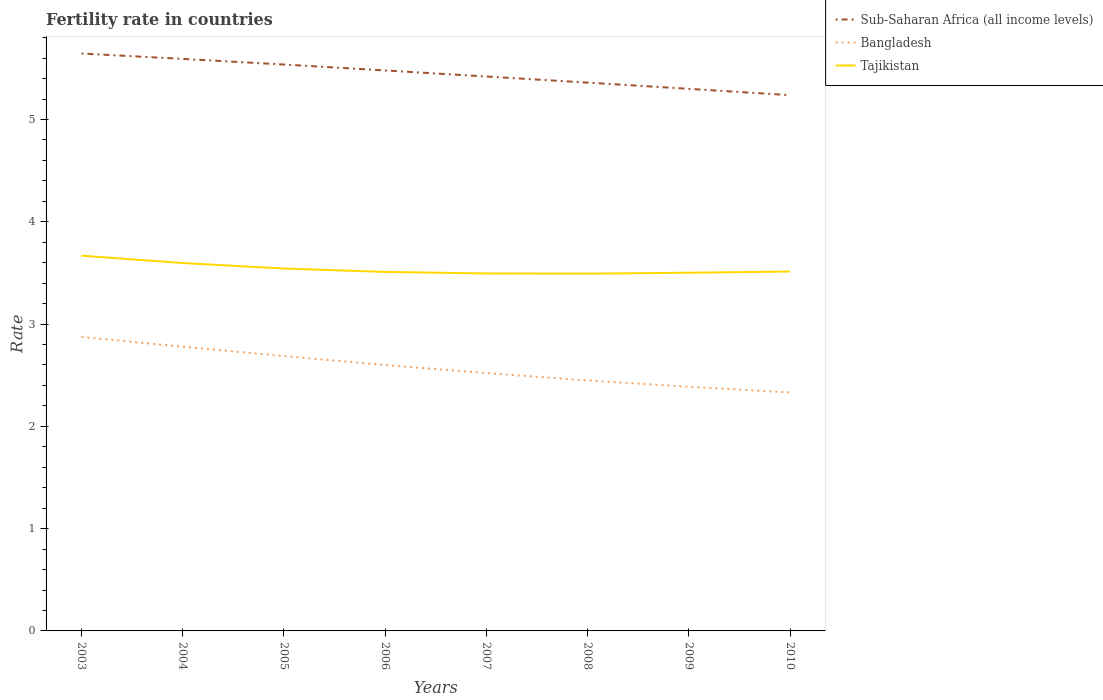Is the number of lines equal to the number of legend labels?
Ensure brevity in your answer.  Yes. Across all years, what is the maximum fertility rate in Sub-Saharan Africa (all income levels)?
Your answer should be compact. 5.24. In which year was the fertility rate in Tajikistan maximum?
Ensure brevity in your answer.  2008. What is the total fertility rate in Sub-Saharan Africa (all income levels) in the graph?
Your answer should be very brief. 0.41. What is the difference between the highest and the second highest fertility rate in Bangladesh?
Ensure brevity in your answer.  0.54. What is the difference between the highest and the lowest fertility rate in Tajikistan?
Your response must be concise. 3. Is the fertility rate in Bangladesh strictly greater than the fertility rate in Tajikistan over the years?
Keep it short and to the point. Yes. How many years are there in the graph?
Offer a very short reply. 8. What is the difference between two consecutive major ticks on the Y-axis?
Offer a terse response. 1. Does the graph contain grids?
Provide a succinct answer. No. Where does the legend appear in the graph?
Provide a succinct answer. Top right. How many legend labels are there?
Ensure brevity in your answer.  3. How are the legend labels stacked?
Offer a very short reply. Vertical. What is the title of the graph?
Your answer should be very brief. Fertility rate in countries. What is the label or title of the X-axis?
Ensure brevity in your answer.  Years. What is the label or title of the Y-axis?
Your answer should be very brief. Rate. What is the Rate of Sub-Saharan Africa (all income levels) in 2003?
Your response must be concise. 5.65. What is the Rate in Bangladesh in 2003?
Offer a very short reply. 2.87. What is the Rate in Tajikistan in 2003?
Offer a terse response. 3.67. What is the Rate in Sub-Saharan Africa (all income levels) in 2004?
Ensure brevity in your answer.  5.59. What is the Rate in Bangladesh in 2004?
Provide a succinct answer. 2.78. What is the Rate of Tajikistan in 2004?
Keep it short and to the point. 3.6. What is the Rate in Sub-Saharan Africa (all income levels) in 2005?
Give a very brief answer. 5.54. What is the Rate in Bangladesh in 2005?
Your response must be concise. 2.69. What is the Rate in Tajikistan in 2005?
Offer a terse response. 3.54. What is the Rate in Sub-Saharan Africa (all income levels) in 2006?
Your answer should be compact. 5.48. What is the Rate of Tajikistan in 2006?
Your response must be concise. 3.51. What is the Rate in Sub-Saharan Africa (all income levels) in 2007?
Your response must be concise. 5.42. What is the Rate of Bangladesh in 2007?
Provide a succinct answer. 2.52. What is the Rate in Tajikistan in 2007?
Provide a succinct answer. 3.5. What is the Rate of Sub-Saharan Africa (all income levels) in 2008?
Ensure brevity in your answer.  5.36. What is the Rate of Bangladesh in 2008?
Your answer should be compact. 2.45. What is the Rate of Tajikistan in 2008?
Your response must be concise. 3.49. What is the Rate in Sub-Saharan Africa (all income levels) in 2009?
Keep it short and to the point. 5.3. What is the Rate of Bangladesh in 2009?
Provide a succinct answer. 2.39. What is the Rate in Tajikistan in 2009?
Keep it short and to the point. 3.5. What is the Rate in Sub-Saharan Africa (all income levels) in 2010?
Provide a succinct answer. 5.24. What is the Rate in Bangladesh in 2010?
Provide a succinct answer. 2.33. What is the Rate of Tajikistan in 2010?
Offer a terse response. 3.51. Across all years, what is the maximum Rate in Sub-Saharan Africa (all income levels)?
Your answer should be very brief. 5.65. Across all years, what is the maximum Rate of Bangladesh?
Provide a succinct answer. 2.87. Across all years, what is the maximum Rate of Tajikistan?
Provide a short and direct response. 3.67. Across all years, what is the minimum Rate in Sub-Saharan Africa (all income levels)?
Your answer should be very brief. 5.24. Across all years, what is the minimum Rate of Bangladesh?
Provide a short and direct response. 2.33. Across all years, what is the minimum Rate of Tajikistan?
Give a very brief answer. 3.49. What is the total Rate in Sub-Saharan Africa (all income levels) in the graph?
Offer a terse response. 43.58. What is the total Rate of Bangladesh in the graph?
Provide a succinct answer. 20.63. What is the total Rate in Tajikistan in the graph?
Provide a succinct answer. 28.32. What is the difference between the Rate in Sub-Saharan Africa (all income levels) in 2003 and that in 2004?
Provide a short and direct response. 0.05. What is the difference between the Rate in Bangladesh in 2003 and that in 2004?
Give a very brief answer. 0.1. What is the difference between the Rate in Tajikistan in 2003 and that in 2004?
Offer a terse response. 0.07. What is the difference between the Rate in Sub-Saharan Africa (all income levels) in 2003 and that in 2005?
Provide a short and direct response. 0.11. What is the difference between the Rate in Bangladesh in 2003 and that in 2005?
Make the answer very short. 0.19. What is the difference between the Rate of Tajikistan in 2003 and that in 2005?
Your answer should be very brief. 0.13. What is the difference between the Rate of Sub-Saharan Africa (all income levels) in 2003 and that in 2006?
Keep it short and to the point. 0.17. What is the difference between the Rate in Bangladesh in 2003 and that in 2006?
Give a very brief answer. 0.27. What is the difference between the Rate of Tajikistan in 2003 and that in 2006?
Your response must be concise. 0.16. What is the difference between the Rate of Sub-Saharan Africa (all income levels) in 2003 and that in 2007?
Ensure brevity in your answer.  0.22. What is the difference between the Rate of Bangladesh in 2003 and that in 2007?
Your response must be concise. 0.35. What is the difference between the Rate of Tajikistan in 2003 and that in 2007?
Your response must be concise. 0.17. What is the difference between the Rate in Sub-Saharan Africa (all income levels) in 2003 and that in 2008?
Keep it short and to the point. 0.28. What is the difference between the Rate of Bangladesh in 2003 and that in 2008?
Make the answer very short. 0.42. What is the difference between the Rate in Tajikistan in 2003 and that in 2008?
Provide a succinct answer. 0.18. What is the difference between the Rate of Sub-Saharan Africa (all income levels) in 2003 and that in 2009?
Keep it short and to the point. 0.35. What is the difference between the Rate in Bangladesh in 2003 and that in 2009?
Ensure brevity in your answer.  0.49. What is the difference between the Rate in Tajikistan in 2003 and that in 2009?
Ensure brevity in your answer.  0.17. What is the difference between the Rate in Sub-Saharan Africa (all income levels) in 2003 and that in 2010?
Your response must be concise. 0.41. What is the difference between the Rate of Bangladesh in 2003 and that in 2010?
Provide a succinct answer. 0.54. What is the difference between the Rate in Tajikistan in 2003 and that in 2010?
Make the answer very short. 0.15. What is the difference between the Rate in Sub-Saharan Africa (all income levels) in 2004 and that in 2005?
Provide a short and direct response. 0.06. What is the difference between the Rate in Bangladesh in 2004 and that in 2005?
Give a very brief answer. 0.09. What is the difference between the Rate in Tajikistan in 2004 and that in 2005?
Ensure brevity in your answer.  0.05. What is the difference between the Rate of Sub-Saharan Africa (all income levels) in 2004 and that in 2006?
Ensure brevity in your answer.  0.11. What is the difference between the Rate in Bangladesh in 2004 and that in 2006?
Offer a terse response. 0.18. What is the difference between the Rate in Tajikistan in 2004 and that in 2006?
Your response must be concise. 0.09. What is the difference between the Rate in Sub-Saharan Africa (all income levels) in 2004 and that in 2007?
Provide a short and direct response. 0.17. What is the difference between the Rate in Bangladesh in 2004 and that in 2007?
Make the answer very short. 0.26. What is the difference between the Rate of Tajikistan in 2004 and that in 2007?
Keep it short and to the point. 0.1. What is the difference between the Rate in Sub-Saharan Africa (all income levels) in 2004 and that in 2008?
Keep it short and to the point. 0.23. What is the difference between the Rate in Bangladesh in 2004 and that in 2008?
Offer a terse response. 0.33. What is the difference between the Rate of Tajikistan in 2004 and that in 2008?
Your answer should be very brief. 0.1. What is the difference between the Rate in Sub-Saharan Africa (all income levels) in 2004 and that in 2009?
Make the answer very short. 0.29. What is the difference between the Rate of Bangladesh in 2004 and that in 2009?
Keep it short and to the point. 0.39. What is the difference between the Rate in Tajikistan in 2004 and that in 2009?
Your answer should be very brief. 0.1. What is the difference between the Rate of Sub-Saharan Africa (all income levels) in 2004 and that in 2010?
Offer a terse response. 0.35. What is the difference between the Rate in Bangladesh in 2004 and that in 2010?
Your answer should be very brief. 0.45. What is the difference between the Rate of Tajikistan in 2004 and that in 2010?
Provide a succinct answer. 0.08. What is the difference between the Rate in Sub-Saharan Africa (all income levels) in 2005 and that in 2006?
Give a very brief answer. 0.06. What is the difference between the Rate in Bangladesh in 2005 and that in 2006?
Your answer should be compact. 0.09. What is the difference between the Rate in Tajikistan in 2005 and that in 2006?
Give a very brief answer. 0.03. What is the difference between the Rate in Sub-Saharan Africa (all income levels) in 2005 and that in 2007?
Provide a succinct answer. 0.12. What is the difference between the Rate of Bangladesh in 2005 and that in 2007?
Provide a short and direct response. 0.17. What is the difference between the Rate in Tajikistan in 2005 and that in 2007?
Ensure brevity in your answer.  0.05. What is the difference between the Rate of Sub-Saharan Africa (all income levels) in 2005 and that in 2008?
Provide a short and direct response. 0.18. What is the difference between the Rate in Bangladesh in 2005 and that in 2008?
Provide a short and direct response. 0.24. What is the difference between the Rate in Tajikistan in 2005 and that in 2008?
Your response must be concise. 0.05. What is the difference between the Rate in Sub-Saharan Africa (all income levels) in 2005 and that in 2009?
Your answer should be very brief. 0.24. What is the difference between the Rate of Bangladesh in 2005 and that in 2009?
Provide a short and direct response. 0.3. What is the difference between the Rate of Tajikistan in 2005 and that in 2009?
Offer a very short reply. 0.04. What is the difference between the Rate in Sub-Saharan Africa (all income levels) in 2005 and that in 2010?
Provide a succinct answer. 0.3. What is the difference between the Rate in Bangladesh in 2005 and that in 2010?
Give a very brief answer. 0.35. What is the difference between the Rate in Tajikistan in 2005 and that in 2010?
Keep it short and to the point. 0.03. What is the difference between the Rate of Sub-Saharan Africa (all income levels) in 2006 and that in 2007?
Give a very brief answer. 0.06. What is the difference between the Rate of Bangladesh in 2006 and that in 2007?
Offer a very short reply. 0.08. What is the difference between the Rate in Tajikistan in 2006 and that in 2007?
Ensure brevity in your answer.  0.01. What is the difference between the Rate in Sub-Saharan Africa (all income levels) in 2006 and that in 2008?
Provide a succinct answer. 0.12. What is the difference between the Rate in Bangladesh in 2006 and that in 2008?
Your answer should be very brief. 0.15. What is the difference between the Rate in Tajikistan in 2006 and that in 2008?
Your response must be concise. 0.02. What is the difference between the Rate in Sub-Saharan Africa (all income levels) in 2006 and that in 2009?
Your answer should be compact. 0.18. What is the difference between the Rate in Bangladesh in 2006 and that in 2009?
Ensure brevity in your answer.  0.21. What is the difference between the Rate of Tajikistan in 2006 and that in 2009?
Your answer should be very brief. 0.01. What is the difference between the Rate of Sub-Saharan Africa (all income levels) in 2006 and that in 2010?
Give a very brief answer. 0.24. What is the difference between the Rate in Bangladesh in 2006 and that in 2010?
Your response must be concise. 0.27. What is the difference between the Rate in Tajikistan in 2006 and that in 2010?
Your answer should be compact. -0. What is the difference between the Rate in Sub-Saharan Africa (all income levels) in 2007 and that in 2008?
Keep it short and to the point. 0.06. What is the difference between the Rate in Bangladesh in 2007 and that in 2008?
Your response must be concise. 0.07. What is the difference between the Rate in Tajikistan in 2007 and that in 2008?
Make the answer very short. 0. What is the difference between the Rate in Sub-Saharan Africa (all income levels) in 2007 and that in 2009?
Make the answer very short. 0.12. What is the difference between the Rate of Bangladesh in 2007 and that in 2009?
Your answer should be compact. 0.13. What is the difference between the Rate of Tajikistan in 2007 and that in 2009?
Keep it short and to the point. -0.01. What is the difference between the Rate in Sub-Saharan Africa (all income levels) in 2007 and that in 2010?
Offer a very short reply. 0.18. What is the difference between the Rate of Bangladesh in 2007 and that in 2010?
Offer a terse response. 0.19. What is the difference between the Rate in Tajikistan in 2007 and that in 2010?
Ensure brevity in your answer.  -0.02. What is the difference between the Rate of Sub-Saharan Africa (all income levels) in 2008 and that in 2009?
Make the answer very short. 0.06. What is the difference between the Rate of Bangladesh in 2008 and that in 2009?
Make the answer very short. 0.06. What is the difference between the Rate of Tajikistan in 2008 and that in 2009?
Offer a very short reply. -0.01. What is the difference between the Rate of Sub-Saharan Africa (all income levels) in 2008 and that in 2010?
Offer a very short reply. 0.12. What is the difference between the Rate of Bangladesh in 2008 and that in 2010?
Keep it short and to the point. 0.12. What is the difference between the Rate in Tajikistan in 2008 and that in 2010?
Give a very brief answer. -0.02. What is the difference between the Rate in Sub-Saharan Africa (all income levels) in 2009 and that in 2010?
Keep it short and to the point. 0.06. What is the difference between the Rate of Bangladesh in 2009 and that in 2010?
Your response must be concise. 0.06. What is the difference between the Rate of Tajikistan in 2009 and that in 2010?
Provide a succinct answer. -0.01. What is the difference between the Rate of Sub-Saharan Africa (all income levels) in 2003 and the Rate of Bangladesh in 2004?
Ensure brevity in your answer.  2.87. What is the difference between the Rate in Sub-Saharan Africa (all income levels) in 2003 and the Rate in Tajikistan in 2004?
Your response must be concise. 2.05. What is the difference between the Rate in Bangladesh in 2003 and the Rate in Tajikistan in 2004?
Your answer should be compact. -0.72. What is the difference between the Rate of Sub-Saharan Africa (all income levels) in 2003 and the Rate of Bangladesh in 2005?
Provide a short and direct response. 2.96. What is the difference between the Rate of Sub-Saharan Africa (all income levels) in 2003 and the Rate of Tajikistan in 2005?
Provide a short and direct response. 2.1. What is the difference between the Rate of Bangladesh in 2003 and the Rate of Tajikistan in 2005?
Offer a very short reply. -0.67. What is the difference between the Rate in Sub-Saharan Africa (all income levels) in 2003 and the Rate in Bangladesh in 2006?
Offer a terse response. 3.05. What is the difference between the Rate in Sub-Saharan Africa (all income levels) in 2003 and the Rate in Tajikistan in 2006?
Ensure brevity in your answer.  2.14. What is the difference between the Rate of Bangladesh in 2003 and the Rate of Tajikistan in 2006?
Ensure brevity in your answer.  -0.64. What is the difference between the Rate of Sub-Saharan Africa (all income levels) in 2003 and the Rate of Bangladesh in 2007?
Provide a short and direct response. 3.12. What is the difference between the Rate of Sub-Saharan Africa (all income levels) in 2003 and the Rate of Tajikistan in 2007?
Ensure brevity in your answer.  2.15. What is the difference between the Rate in Bangladesh in 2003 and the Rate in Tajikistan in 2007?
Give a very brief answer. -0.62. What is the difference between the Rate of Sub-Saharan Africa (all income levels) in 2003 and the Rate of Bangladesh in 2008?
Your answer should be very brief. 3.2. What is the difference between the Rate in Sub-Saharan Africa (all income levels) in 2003 and the Rate in Tajikistan in 2008?
Provide a succinct answer. 2.15. What is the difference between the Rate in Bangladesh in 2003 and the Rate in Tajikistan in 2008?
Your answer should be very brief. -0.62. What is the difference between the Rate of Sub-Saharan Africa (all income levels) in 2003 and the Rate of Bangladesh in 2009?
Give a very brief answer. 3.26. What is the difference between the Rate of Sub-Saharan Africa (all income levels) in 2003 and the Rate of Tajikistan in 2009?
Keep it short and to the point. 2.14. What is the difference between the Rate of Bangladesh in 2003 and the Rate of Tajikistan in 2009?
Offer a very short reply. -0.63. What is the difference between the Rate in Sub-Saharan Africa (all income levels) in 2003 and the Rate in Bangladesh in 2010?
Your answer should be very brief. 3.31. What is the difference between the Rate in Sub-Saharan Africa (all income levels) in 2003 and the Rate in Tajikistan in 2010?
Provide a succinct answer. 2.13. What is the difference between the Rate of Bangladesh in 2003 and the Rate of Tajikistan in 2010?
Make the answer very short. -0.64. What is the difference between the Rate of Sub-Saharan Africa (all income levels) in 2004 and the Rate of Bangladesh in 2005?
Keep it short and to the point. 2.91. What is the difference between the Rate in Sub-Saharan Africa (all income levels) in 2004 and the Rate in Tajikistan in 2005?
Provide a succinct answer. 2.05. What is the difference between the Rate of Bangladesh in 2004 and the Rate of Tajikistan in 2005?
Your response must be concise. -0.76. What is the difference between the Rate of Sub-Saharan Africa (all income levels) in 2004 and the Rate of Bangladesh in 2006?
Provide a short and direct response. 2.99. What is the difference between the Rate of Sub-Saharan Africa (all income levels) in 2004 and the Rate of Tajikistan in 2006?
Your answer should be very brief. 2.08. What is the difference between the Rate in Bangladesh in 2004 and the Rate in Tajikistan in 2006?
Provide a short and direct response. -0.73. What is the difference between the Rate in Sub-Saharan Africa (all income levels) in 2004 and the Rate in Bangladesh in 2007?
Ensure brevity in your answer.  3.07. What is the difference between the Rate of Sub-Saharan Africa (all income levels) in 2004 and the Rate of Tajikistan in 2007?
Provide a succinct answer. 2.1. What is the difference between the Rate of Bangladesh in 2004 and the Rate of Tajikistan in 2007?
Your response must be concise. -0.72. What is the difference between the Rate in Sub-Saharan Africa (all income levels) in 2004 and the Rate in Bangladesh in 2008?
Your response must be concise. 3.14. What is the difference between the Rate in Sub-Saharan Africa (all income levels) in 2004 and the Rate in Tajikistan in 2008?
Provide a short and direct response. 2.1. What is the difference between the Rate in Bangladesh in 2004 and the Rate in Tajikistan in 2008?
Your answer should be very brief. -0.71. What is the difference between the Rate in Sub-Saharan Africa (all income levels) in 2004 and the Rate in Bangladesh in 2009?
Give a very brief answer. 3.21. What is the difference between the Rate in Sub-Saharan Africa (all income levels) in 2004 and the Rate in Tajikistan in 2009?
Ensure brevity in your answer.  2.09. What is the difference between the Rate of Bangladesh in 2004 and the Rate of Tajikistan in 2009?
Ensure brevity in your answer.  -0.72. What is the difference between the Rate of Sub-Saharan Africa (all income levels) in 2004 and the Rate of Bangladesh in 2010?
Provide a short and direct response. 3.26. What is the difference between the Rate of Sub-Saharan Africa (all income levels) in 2004 and the Rate of Tajikistan in 2010?
Keep it short and to the point. 2.08. What is the difference between the Rate of Bangladesh in 2004 and the Rate of Tajikistan in 2010?
Your answer should be very brief. -0.73. What is the difference between the Rate in Sub-Saharan Africa (all income levels) in 2005 and the Rate in Bangladesh in 2006?
Keep it short and to the point. 2.94. What is the difference between the Rate of Sub-Saharan Africa (all income levels) in 2005 and the Rate of Tajikistan in 2006?
Your answer should be compact. 2.03. What is the difference between the Rate in Bangladesh in 2005 and the Rate in Tajikistan in 2006?
Your answer should be very brief. -0.82. What is the difference between the Rate of Sub-Saharan Africa (all income levels) in 2005 and the Rate of Bangladesh in 2007?
Give a very brief answer. 3.02. What is the difference between the Rate of Sub-Saharan Africa (all income levels) in 2005 and the Rate of Tajikistan in 2007?
Make the answer very short. 2.04. What is the difference between the Rate of Bangladesh in 2005 and the Rate of Tajikistan in 2007?
Offer a very short reply. -0.81. What is the difference between the Rate of Sub-Saharan Africa (all income levels) in 2005 and the Rate of Bangladesh in 2008?
Provide a succinct answer. 3.09. What is the difference between the Rate in Sub-Saharan Africa (all income levels) in 2005 and the Rate in Tajikistan in 2008?
Your answer should be compact. 2.04. What is the difference between the Rate of Bangladesh in 2005 and the Rate of Tajikistan in 2008?
Offer a terse response. -0.81. What is the difference between the Rate in Sub-Saharan Africa (all income levels) in 2005 and the Rate in Bangladesh in 2009?
Ensure brevity in your answer.  3.15. What is the difference between the Rate in Sub-Saharan Africa (all income levels) in 2005 and the Rate in Tajikistan in 2009?
Your answer should be compact. 2.04. What is the difference between the Rate of Bangladesh in 2005 and the Rate of Tajikistan in 2009?
Keep it short and to the point. -0.81. What is the difference between the Rate of Sub-Saharan Africa (all income levels) in 2005 and the Rate of Bangladesh in 2010?
Your answer should be compact. 3.21. What is the difference between the Rate of Sub-Saharan Africa (all income levels) in 2005 and the Rate of Tajikistan in 2010?
Provide a succinct answer. 2.02. What is the difference between the Rate in Bangladesh in 2005 and the Rate in Tajikistan in 2010?
Keep it short and to the point. -0.83. What is the difference between the Rate in Sub-Saharan Africa (all income levels) in 2006 and the Rate in Bangladesh in 2007?
Offer a terse response. 2.96. What is the difference between the Rate in Sub-Saharan Africa (all income levels) in 2006 and the Rate in Tajikistan in 2007?
Your answer should be compact. 1.98. What is the difference between the Rate in Bangladesh in 2006 and the Rate in Tajikistan in 2007?
Your response must be concise. -0.9. What is the difference between the Rate of Sub-Saharan Africa (all income levels) in 2006 and the Rate of Bangladesh in 2008?
Your answer should be very brief. 3.03. What is the difference between the Rate in Sub-Saharan Africa (all income levels) in 2006 and the Rate in Tajikistan in 2008?
Provide a succinct answer. 1.99. What is the difference between the Rate of Bangladesh in 2006 and the Rate of Tajikistan in 2008?
Provide a succinct answer. -0.89. What is the difference between the Rate in Sub-Saharan Africa (all income levels) in 2006 and the Rate in Bangladesh in 2009?
Your response must be concise. 3.09. What is the difference between the Rate of Sub-Saharan Africa (all income levels) in 2006 and the Rate of Tajikistan in 2009?
Ensure brevity in your answer.  1.98. What is the difference between the Rate of Bangladesh in 2006 and the Rate of Tajikistan in 2009?
Keep it short and to the point. -0.9. What is the difference between the Rate of Sub-Saharan Africa (all income levels) in 2006 and the Rate of Bangladesh in 2010?
Make the answer very short. 3.15. What is the difference between the Rate in Sub-Saharan Africa (all income levels) in 2006 and the Rate in Tajikistan in 2010?
Offer a very short reply. 1.97. What is the difference between the Rate in Bangladesh in 2006 and the Rate in Tajikistan in 2010?
Make the answer very short. -0.91. What is the difference between the Rate of Sub-Saharan Africa (all income levels) in 2007 and the Rate of Bangladesh in 2008?
Provide a short and direct response. 2.97. What is the difference between the Rate in Sub-Saharan Africa (all income levels) in 2007 and the Rate in Tajikistan in 2008?
Your answer should be very brief. 1.93. What is the difference between the Rate of Bangladesh in 2007 and the Rate of Tajikistan in 2008?
Ensure brevity in your answer.  -0.97. What is the difference between the Rate in Sub-Saharan Africa (all income levels) in 2007 and the Rate in Bangladesh in 2009?
Give a very brief answer. 3.03. What is the difference between the Rate in Sub-Saharan Africa (all income levels) in 2007 and the Rate in Tajikistan in 2009?
Provide a short and direct response. 1.92. What is the difference between the Rate of Bangladesh in 2007 and the Rate of Tajikistan in 2009?
Your answer should be compact. -0.98. What is the difference between the Rate of Sub-Saharan Africa (all income levels) in 2007 and the Rate of Bangladesh in 2010?
Keep it short and to the point. 3.09. What is the difference between the Rate in Sub-Saharan Africa (all income levels) in 2007 and the Rate in Tajikistan in 2010?
Provide a short and direct response. 1.91. What is the difference between the Rate of Bangladesh in 2007 and the Rate of Tajikistan in 2010?
Ensure brevity in your answer.  -0.99. What is the difference between the Rate of Sub-Saharan Africa (all income levels) in 2008 and the Rate of Bangladesh in 2009?
Keep it short and to the point. 2.97. What is the difference between the Rate in Sub-Saharan Africa (all income levels) in 2008 and the Rate in Tajikistan in 2009?
Keep it short and to the point. 1.86. What is the difference between the Rate in Bangladesh in 2008 and the Rate in Tajikistan in 2009?
Ensure brevity in your answer.  -1.05. What is the difference between the Rate in Sub-Saharan Africa (all income levels) in 2008 and the Rate in Bangladesh in 2010?
Provide a short and direct response. 3.03. What is the difference between the Rate of Sub-Saharan Africa (all income levels) in 2008 and the Rate of Tajikistan in 2010?
Keep it short and to the point. 1.85. What is the difference between the Rate in Bangladesh in 2008 and the Rate in Tajikistan in 2010?
Give a very brief answer. -1.06. What is the difference between the Rate of Sub-Saharan Africa (all income levels) in 2009 and the Rate of Bangladesh in 2010?
Provide a short and direct response. 2.97. What is the difference between the Rate in Sub-Saharan Africa (all income levels) in 2009 and the Rate in Tajikistan in 2010?
Your answer should be very brief. 1.79. What is the difference between the Rate in Bangladesh in 2009 and the Rate in Tajikistan in 2010?
Make the answer very short. -1.13. What is the average Rate of Sub-Saharan Africa (all income levels) per year?
Your answer should be very brief. 5.45. What is the average Rate of Bangladesh per year?
Provide a short and direct response. 2.58. What is the average Rate in Tajikistan per year?
Offer a terse response. 3.54. In the year 2003, what is the difference between the Rate in Sub-Saharan Africa (all income levels) and Rate in Bangladesh?
Offer a terse response. 2.77. In the year 2003, what is the difference between the Rate of Sub-Saharan Africa (all income levels) and Rate of Tajikistan?
Your answer should be compact. 1.98. In the year 2003, what is the difference between the Rate of Bangladesh and Rate of Tajikistan?
Ensure brevity in your answer.  -0.8. In the year 2004, what is the difference between the Rate in Sub-Saharan Africa (all income levels) and Rate in Bangladesh?
Your answer should be very brief. 2.81. In the year 2004, what is the difference between the Rate in Sub-Saharan Africa (all income levels) and Rate in Tajikistan?
Provide a succinct answer. 2. In the year 2004, what is the difference between the Rate of Bangladesh and Rate of Tajikistan?
Make the answer very short. -0.82. In the year 2005, what is the difference between the Rate in Sub-Saharan Africa (all income levels) and Rate in Bangladesh?
Make the answer very short. 2.85. In the year 2005, what is the difference between the Rate in Sub-Saharan Africa (all income levels) and Rate in Tajikistan?
Ensure brevity in your answer.  1.99. In the year 2005, what is the difference between the Rate in Bangladesh and Rate in Tajikistan?
Offer a terse response. -0.86. In the year 2006, what is the difference between the Rate in Sub-Saharan Africa (all income levels) and Rate in Bangladesh?
Your answer should be compact. 2.88. In the year 2006, what is the difference between the Rate of Sub-Saharan Africa (all income levels) and Rate of Tajikistan?
Give a very brief answer. 1.97. In the year 2006, what is the difference between the Rate in Bangladesh and Rate in Tajikistan?
Offer a terse response. -0.91. In the year 2007, what is the difference between the Rate in Sub-Saharan Africa (all income levels) and Rate in Bangladesh?
Provide a short and direct response. 2.9. In the year 2007, what is the difference between the Rate of Sub-Saharan Africa (all income levels) and Rate of Tajikistan?
Provide a succinct answer. 1.93. In the year 2007, what is the difference between the Rate of Bangladesh and Rate of Tajikistan?
Offer a terse response. -0.97. In the year 2008, what is the difference between the Rate of Sub-Saharan Africa (all income levels) and Rate of Bangladesh?
Ensure brevity in your answer.  2.91. In the year 2008, what is the difference between the Rate of Sub-Saharan Africa (all income levels) and Rate of Tajikistan?
Your answer should be compact. 1.87. In the year 2008, what is the difference between the Rate in Bangladesh and Rate in Tajikistan?
Your response must be concise. -1.04. In the year 2009, what is the difference between the Rate of Sub-Saharan Africa (all income levels) and Rate of Bangladesh?
Keep it short and to the point. 2.91. In the year 2009, what is the difference between the Rate of Sub-Saharan Africa (all income levels) and Rate of Tajikistan?
Make the answer very short. 1.8. In the year 2009, what is the difference between the Rate of Bangladesh and Rate of Tajikistan?
Provide a short and direct response. -1.11. In the year 2010, what is the difference between the Rate in Sub-Saharan Africa (all income levels) and Rate in Bangladesh?
Provide a short and direct response. 2.91. In the year 2010, what is the difference between the Rate in Sub-Saharan Africa (all income levels) and Rate in Tajikistan?
Keep it short and to the point. 1.72. In the year 2010, what is the difference between the Rate in Bangladesh and Rate in Tajikistan?
Your response must be concise. -1.18. What is the ratio of the Rate in Sub-Saharan Africa (all income levels) in 2003 to that in 2004?
Give a very brief answer. 1.01. What is the ratio of the Rate of Bangladesh in 2003 to that in 2004?
Your answer should be compact. 1.03. What is the ratio of the Rate of Sub-Saharan Africa (all income levels) in 2003 to that in 2005?
Your response must be concise. 1.02. What is the ratio of the Rate in Bangladesh in 2003 to that in 2005?
Ensure brevity in your answer.  1.07. What is the ratio of the Rate of Tajikistan in 2003 to that in 2005?
Your response must be concise. 1.04. What is the ratio of the Rate in Sub-Saharan Africa (all income levels) in 2003 to that in 2006?
Your answer should be compact. 1.03. What is the ratio of the Rate of Bangladesh in 2003 to that in 2006?
Ensure brevity in your answer.  1.11. What is the ratio of the Rate of Tajikistan in 2003 to that in 2006?
Your response must be concise. 1.05. What is the ratio of the Rate in Sub-Saharan Africa (all income levels) in 2003 to that in 2007?
Offer a very short reply. 1.04. What is the ratio of the Rate of Bangladesh in 2003 to that in 2007?
Your answer should be very brief. 1.14. What is the ratio of the Rate in Tajikistan in 2003 to that in 2007?
Offer a terse response. 1.05. What is the ratio of the Rate of Sub-Saharan Africa (all income levels) in 2003 to that in 2008?
Offer a very short reply. 1.05. What is the ratio of the Rate of Bangladesh in 2003 to that in 2008?
Offer a terse response. 1.17. What is the ratio of the Rate in Tajikistan in 2003 to that in 2008?
Make the answer very short. 1.05. What is the ratio of the Rate in Sub-Saharan Africa (all income levels) in 2003 to that in 2009?
Your answer should be very brief. 1.07. What is the ratio of the Rate in Bangladesh in 2003 to that in 2009?
Keep it short and to the point. 1.2. What is the ratio of the Rate of Tajikistan in 2003 to that in 2009?
Offer a very short reply. 1.05. What is the ratio of the Rate of Sub-Saharan Africa (all income levels) in 2003 to that in 2010?
Ensure brevity in your answer.  1.08. What is the ratio of the Rate of Bangladesh in 2003 to that in 2010?
Your response must be concise. 1.23. What is the ratio of the Rate of Tajikistan in 2003 to that in 2010?
Your answer should be compact. 1.04. What is the ratio of the Rate of Bangladesh in 2004 to that in 2005?
Give a very brief answer. 1.03. What is the ratio of the Rate of Tajikistan in 2004 to that in 2005?
Provide a short and direct response. 1.02. What is the ratio of the Rate in Sub-Saharan Africa (all income levels) in 2004 to that in 2006?
Keep it short and to the point. 1.02. What is the ratio of the Rate of Bangladesh in 2004 to that in 2006?
Provide a succinct answer. 1.07. What is the ratio of the Rate in Tajikistan in 2004 to that in 2006?
Provide a succinct answer. 1.02. What is the ratio of the Rate of Sub-Saharan Africa (all income levels) in 2004 to that in 2007?
Offer a very short reply. 1.03. What is the ratio of the Rate of Bangladesh in 2004 to that in 2007?
Keep it short and to the point. 1.1. What is the ratio of the Rate in Tajikistan in 2004 to that in 2007?
Your answer should be compact. 1.03. What is the ratio of the Rate of Sub-Saharan Africa (all income levels) in 2004 to that in 2008?
Your answer should be compact. 1.04. What is the ratio of the Rate of Bangladesh in 2004 to that in 2008?
Make the answer very short. 1.13. What is the ratio of the Rate of Tajikistan in 2004 to that in 2008?
Provide a succinct answer. 1.03. What is the ratio of the Rate of Sub-Saharan Africa (all income levels) in 2004 to that in 2009?
Provide a succinct answer. 1.06. What is the ratio of the Rate of Bangladesh in 2004 to that in 2009?
Provide a succinct answer. 1.16. What is the ratio of the Rate in Tajikistan in 2004 to that in 2009?
Your answer should be very brief. 1.03. What is the ratio of the Rate of Sub-Saharan Africa (all income levels) in 2004 to that in 2010?
Provide a short and direct response. 1.07. What is the ratio of the Rate of Bangladesh in 2004 to that in 2010?
Your answer should be compact. 1.19. What is the ratio of the Rate in Tajikistan in 2004 to that in 2010?
Provide a short and direct response. 1.02. What is the ratio of the Rate of Sub-Saharan Africa (all income levels) in 2005 to that in 2006?
Your answer should be compact. 1.01. What is the ratio of the Rate in Bangladesh in 2005 to that in 2006?
Make the answer very short. 1.03. What is the ratio of the Rate of Tajikistan in 2005 to that in 2006?
Your response must be concise. 1.01. What is the ratio of the Rate of Sub-Saharan Africa (all income levels) in 2005 to that in 2007?
Provide a succinct answer. 1.02. What is the ratio of the Rate in Bangladesh in 2005 to that in 2007?
Keep it short and to the point. 1.07. What is the ratio of the Rate in Tajikistan in 2005 to that in 2007?
Offer a very short reply. 1.01. What is the ratio of the Rate of Sub-Saharan Africa (all income levels) in 2005 to that in 2008?
Give a very brief answer. 1.03. What is the ratio of the Rate in Bangladesh in 2005 to that in 2008?
Offer a very short reply. 1.1. What is the ratio of the Rate in Tajikistan in 2005 to that in 2008?
Provide a short and direct response. 1.01. What is the ratio of the Rate of Sub-Saharan Africa (all income levels) in 2005 to that in 2009?
Ensure brevity in your answer.  1.04. What is the ratio of the Rate of Bangladesh in 2005 to that in 2009?
Give a very brief answer. 1.13. What is the ratio of the Rate in Tajikistan in 2005 to that in 2009?
Keep it short and to the point. 1.01. What is the ratio of the Rate of Sub-Saharan Africa (all income levels) in 2005 to that in 2010?
Keep it short and to the point. 1.06. What is the ratio of the Rate of Bangladesh in 2005 to that in 2010?
Give a very brief answer. 1.15. What is the ratio of the Rate in Tajikistan in 2005 to that in 2010?
Give a very brief answer. 1.01. What is the ratio of the Rate of Sub-Saharan Africa (all income levels) in 2006 to that in 2007?
Your response must be concise. 1.01. What is the ratio of the Rate in Bangladesh in 2006 to that in 2007?
Keep it short and to the point. 1.03. What is the ratio of the Rate in Sub-Saharan Africa (all income levels) in 2006 to that in 2008?
Your response must be concise. 1.02. What is the ratio of the Rate of Bangladesh in 2006 to that in 2008?
Offer a terse response. 1.06. What is the ratio of the Rate of Sub-Saharan Africa (all income levels) in 2006 to that in 2009?
Offer a terse response. 1.03. What is the ratio of the Rate of Bangladesh in 2006 to that in 2009?
Your response must be concise. 1.09. What is the ratio of the Rate in Sub-Saharan Africa (all income levels) in 2006 to that in 2010?
Offer a very short reply. 1.05. What is the ratio of the Rate of Bangladesh in 2006 to that in 2010?
Keep it short and to the point. 1.11. What is the ratio of the Rate of Tajikistan in 2006 to that in 2010?
Make the answer very short. 1. What is the ratio of the Rate in Sub-Saharan Africa (all income levels) in 2007 to that in 2008?
Give a very brief answer. 1.01. What is the ratio of the Rate of Bangladesh in 2007 to that in 2008?
Offer a terse response. 1.03. What is the ratio of the Rate of Tajikistan in 2007 to that in 2008?
Offer a terse response. 1. What is the ratio of the Rate of Sub-Saharan Africa (all income levels) in 2007 to that in 2009?
Provide a short and direct response. 1.02. What is the ratio of the Rate of Bangladesh in 2007 to that in 2009?
Your response must be concise. 1.06. What is the ratio of the Rate in Tajikistan in 2007 to that in 2009?
Your response must be concise. 1. What is the ratio of the Rate in Sub-Saharan Africa (all income levels) in 2007 to that in 2010?
Give a very brief answer. 1.03. What is the ratio of the Rate in Bangladesh in 2007 to that in 2010?
Offer a terse response. 1.08. What is the ratio of the Rate of Tajikistan in 2007 to that in 2010?
Offer a very short reply. 0.99. What is the ratio of the Rate in Sub-Saharan Africa (all income levels) in 2008 to that in 2009?
Your answer should be very brief. 1.01. What is the ratio of the Rate of Bangladesh in 2008 to that in 2009?
Offer a very short reply. 1.03. What is the ratio of the Rate in Sub-Saharan Africa (all income levels) in 2008 to that in 2010?
Provide a succinct answer. 1.02. What is the ratio of the Rate in Bangladesh in 2008 to that in 2010?
Keep it short and to the point. 1.05. What is the ratio of the Rate of Sub-Saharan Africa (all income levels) in 2009 to that in 2010?
Your response must be concise. 1.01. What is the ratio of the Rate of Bangladesh in 2009 to that in 2010?
Ensure brevity in your answer.  1.02. What is the difference between the highest and the second highest Rate in Sub-Saharan Africa (all income levels)?
Your answer should be very brief. 0.05. What is the difference between the highest and the second highest Rate in Bangladesh?
Offer a very short reply. 0.1. What is the difference between the highest and the second highest Rate of Tajikistan?
Provide a succinct answer. 0.07. What is the difference between the highest and the lowest Rate of Sub-Saharan Africa (all income levels)?
Make the answer very short. 0.41. What is the difference between the highest and the lowest Rate of Bangladesh?
Your answer should be very brief. 0.54. What is the difference between the highest and the lowest Rate of Tajikistan?
Offer a terse response. 0.18. 